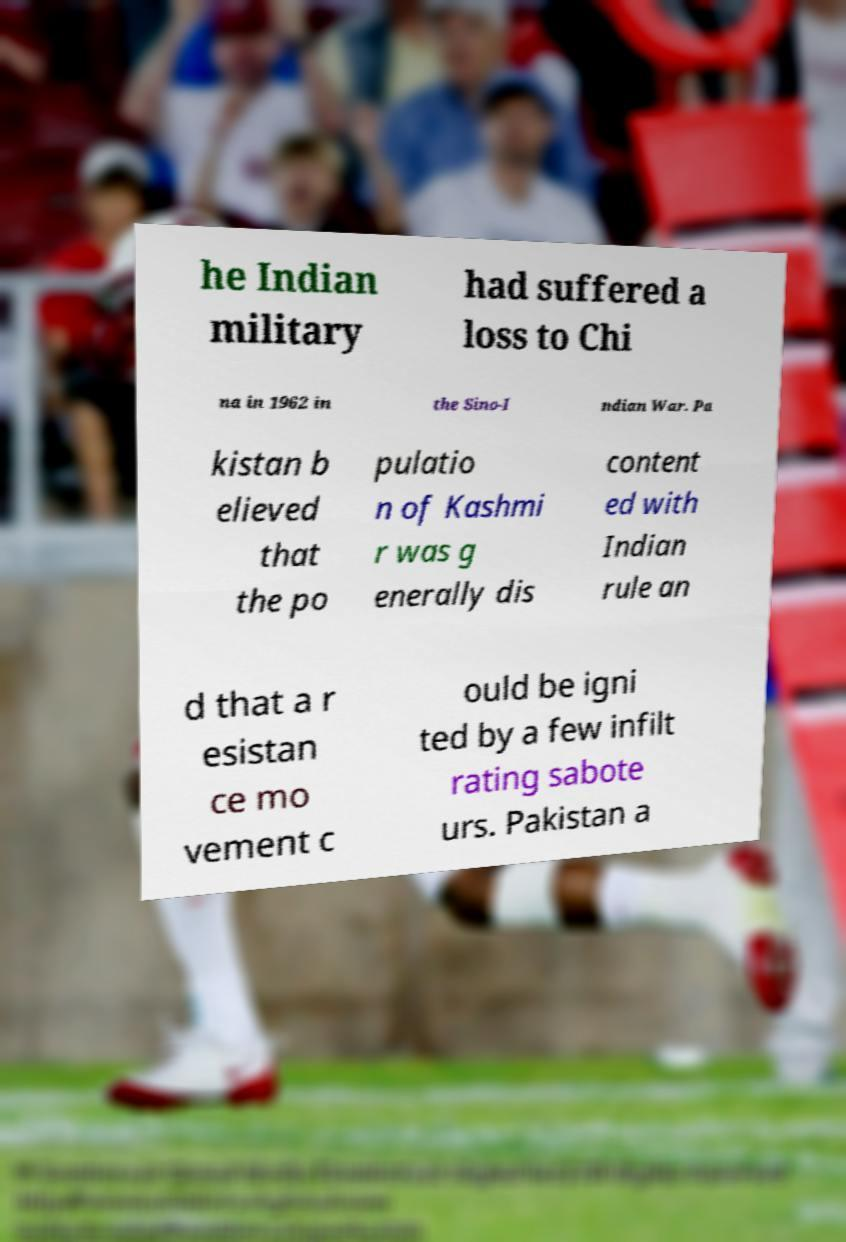Could you assist in decoding the text presented in this image and type it out clearly? he Indian military had suffered a loss to Chi na in 1962 in the Sino-I ndian War. Pa kistan b elieved that the po pulatio n of Kashmi r was g enerally dis content ed with Indian rule an d that a r esistan ce mo vement c ould be igni ted by a few infilt rating sabote urs. Pakistan a 